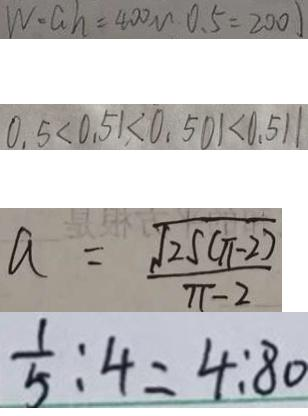Convert formula to latex. <formula><loc_0><loc_0><loc_500><loc_500>W = a h = 4 0 0 m 0 . 5 = 2 0 0 ) 
 0 . 5 < 0 . 5 1 < 0 . 5 0 1 < 0 . 5 1 1 
 a = \frac { \sqrt { 2 5 ( \pi - 2 ) } } { \pi - 2 } 
 \frac { 1 } { 5 } : 4 = 4 : 8 0</formula> 